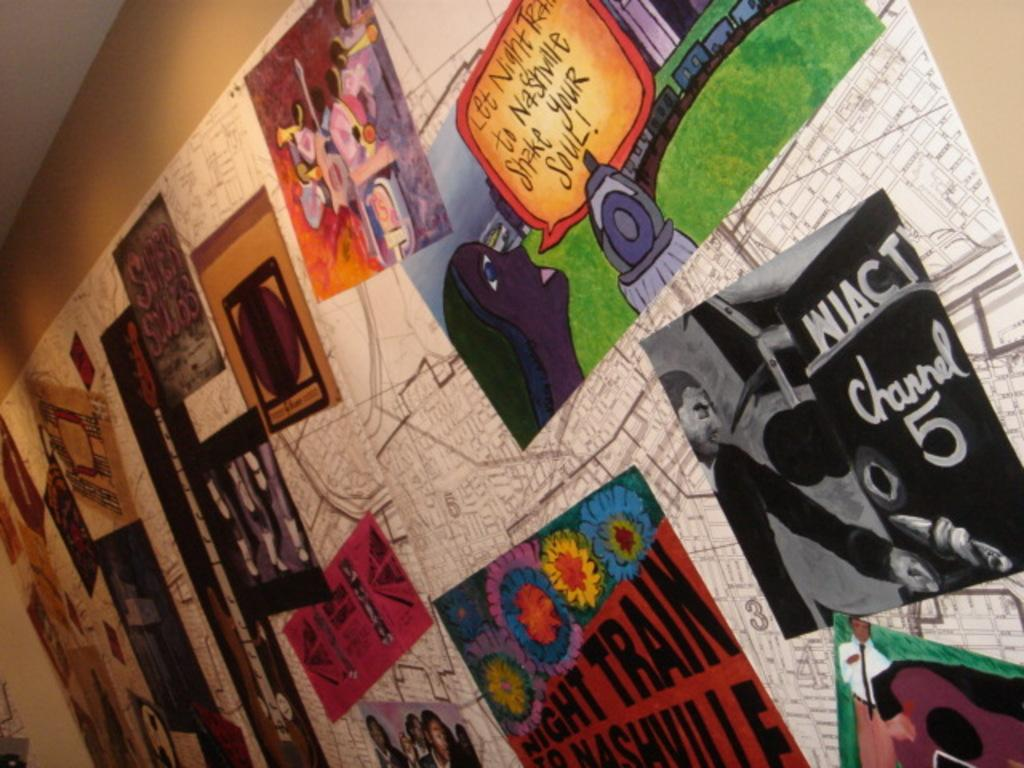Provide a one-sentence caption for the provided image. Wall with pictures on it and one saying " Let Night Train to Nashville Shake Your Soul". 